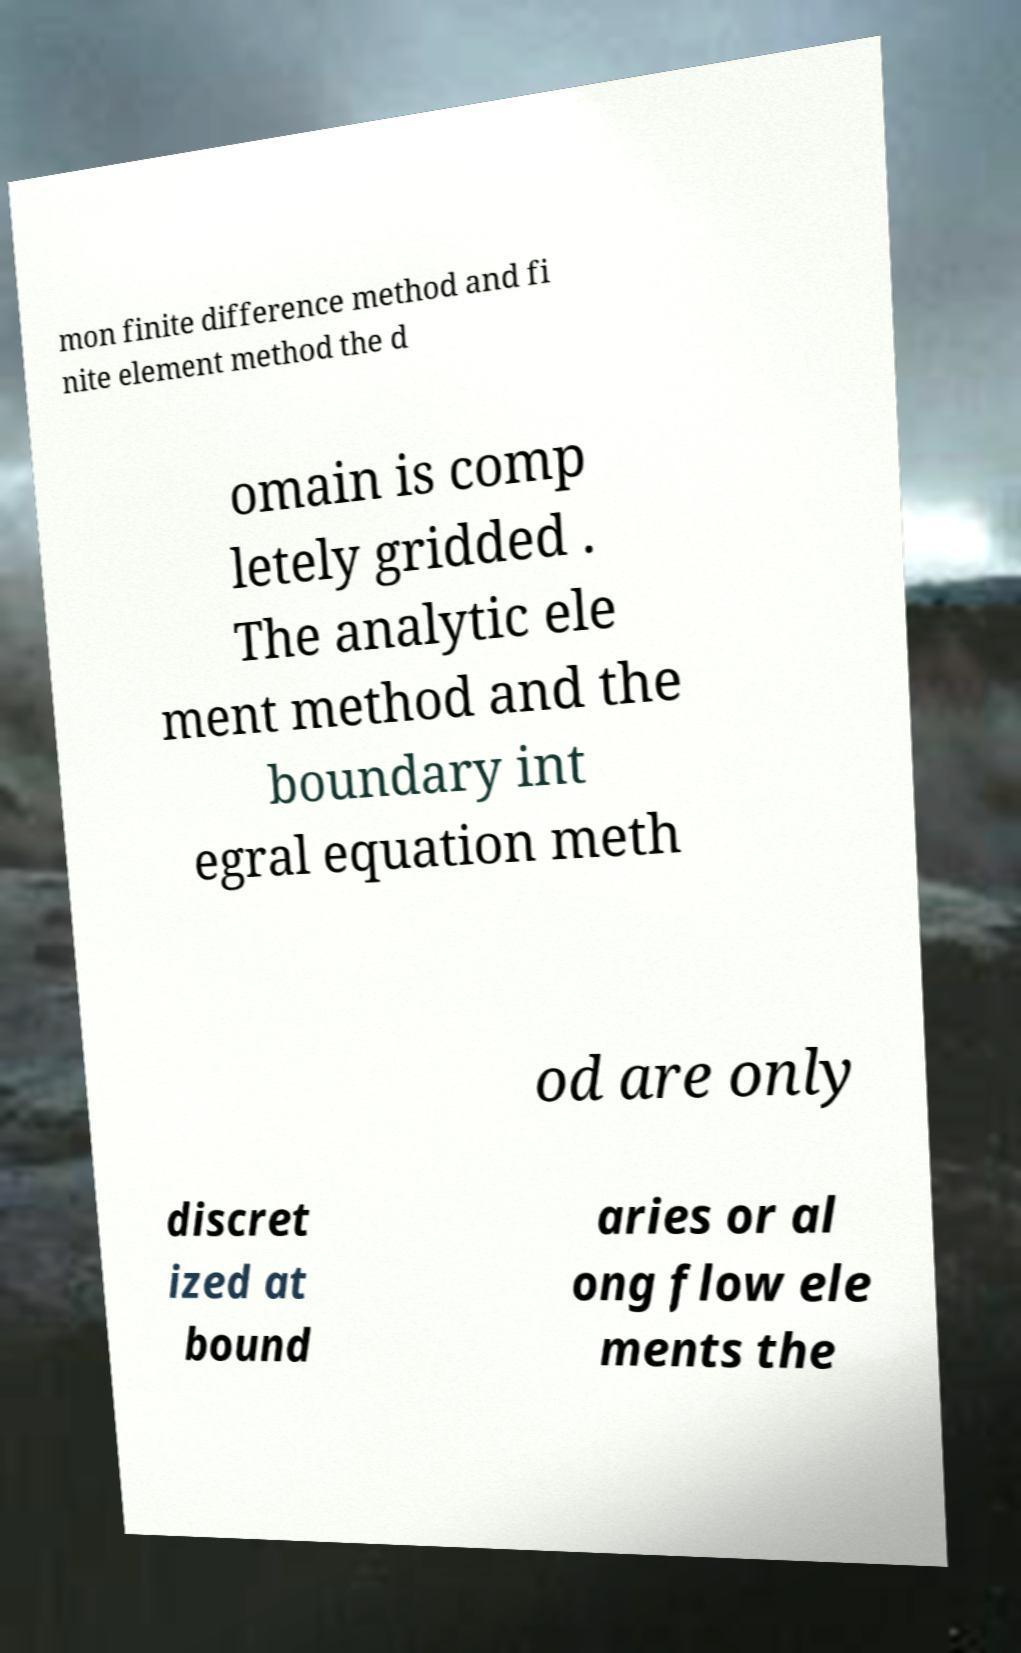Please identify and transcribe the text found in this image. mon finite difference method and fi nite element method the d omain is comp letely gridded . The analytic ele ment method and the boundary int egral equation meth od are only discret ized at bound aries or al ong flow ele ments the 